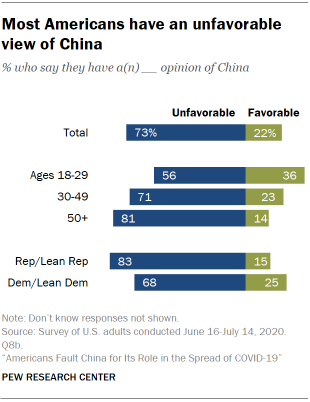Point out several critical features in this image. The percentage value in favorable ratings for ages 30-49 is 23%. The ratio between favorable and unfavorable opinions in the total category is 0.967361111... 